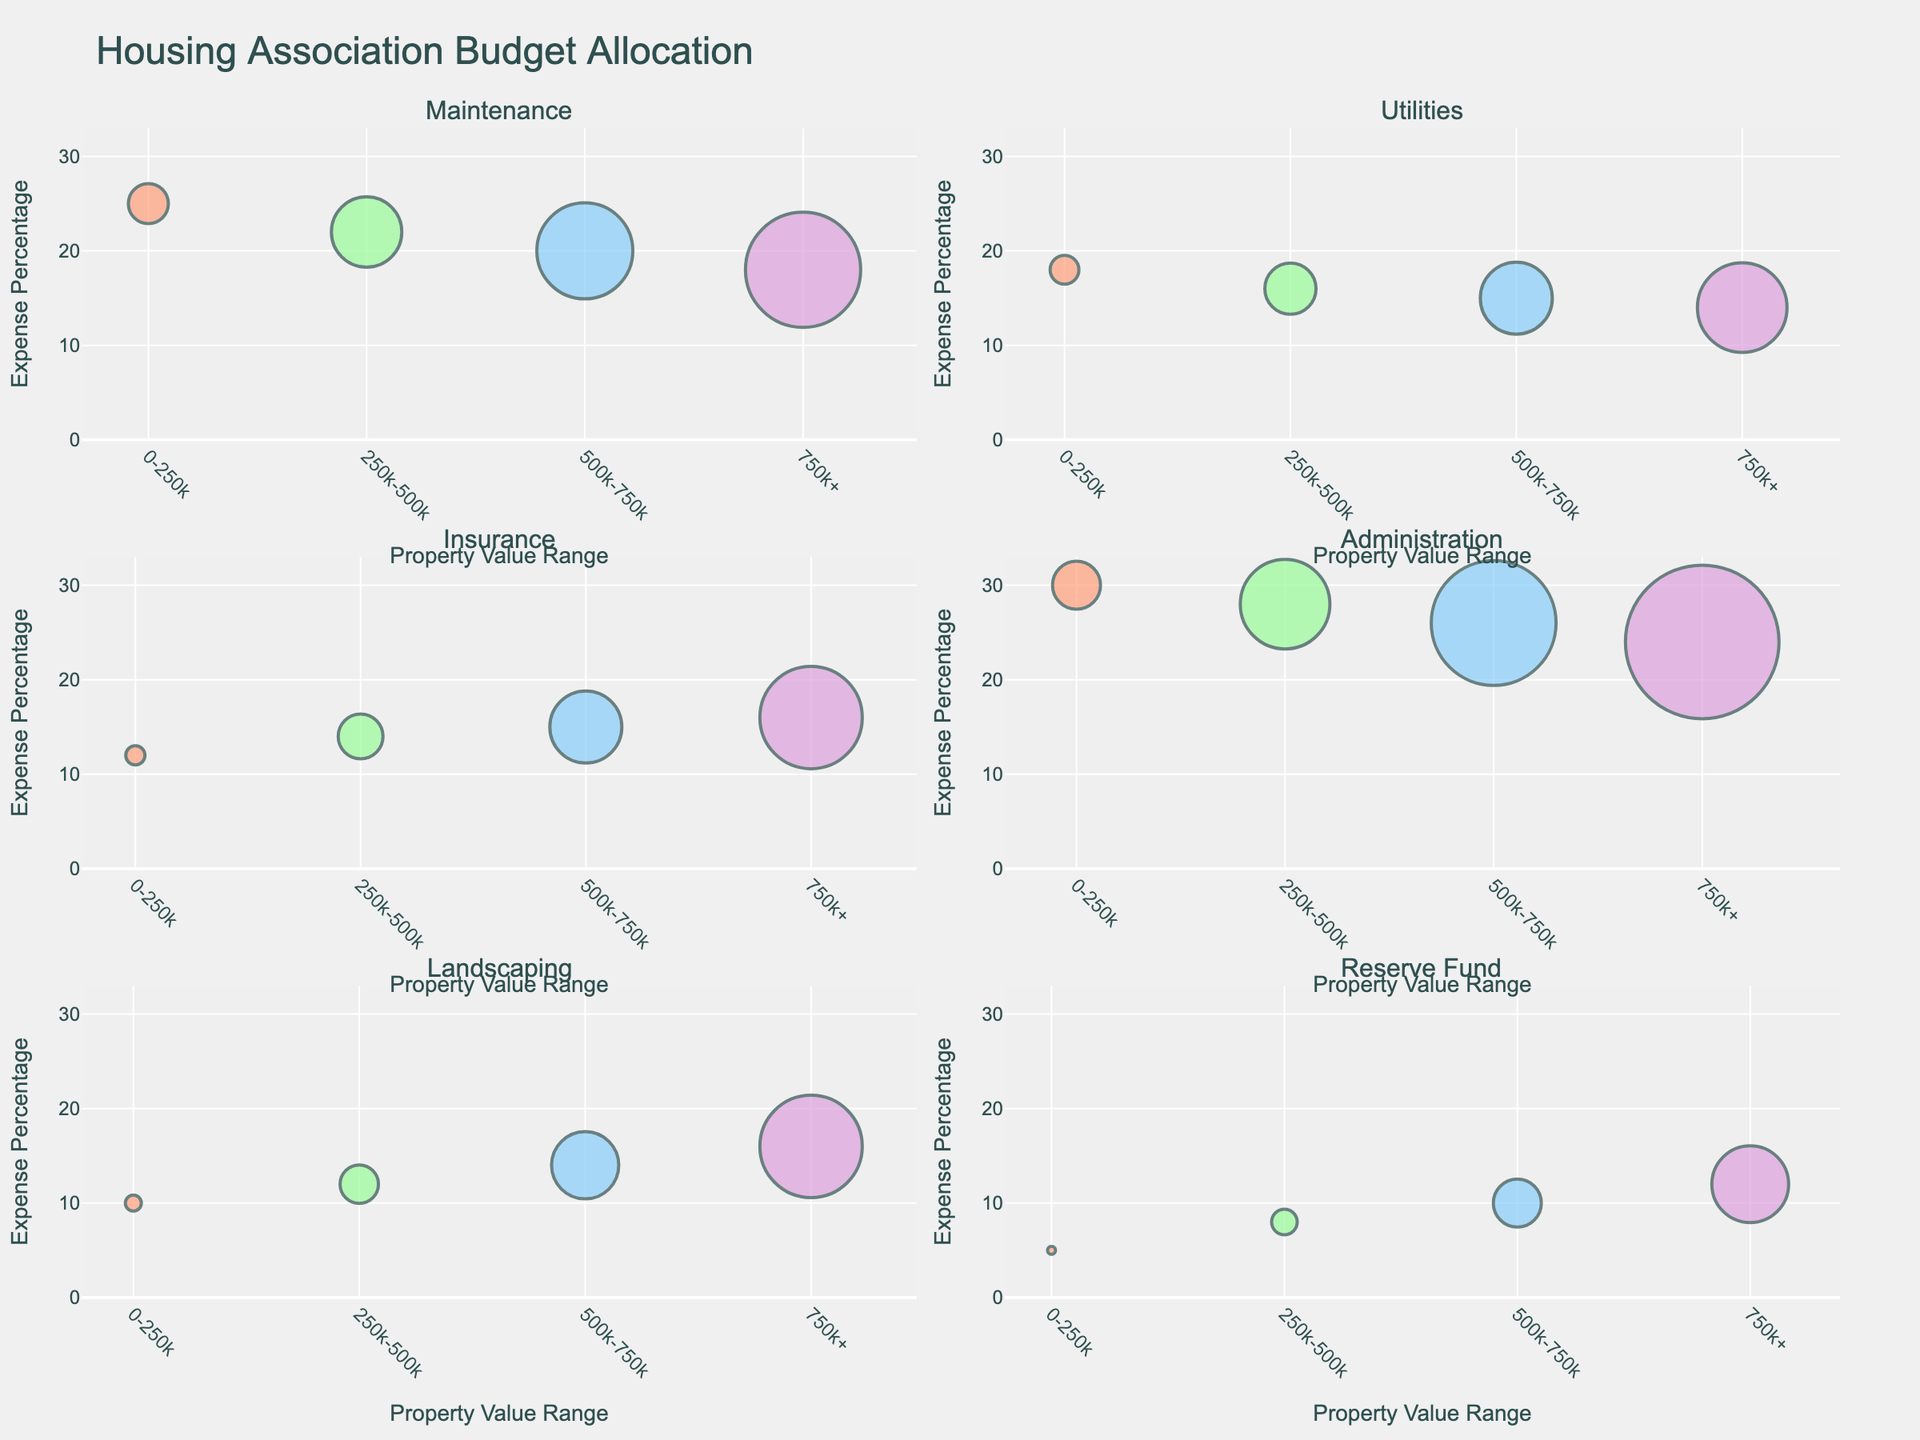What is the title of the figure? The title is located at the top-center of the figure. It is typically meant to provide a succinct description of what the figure is about.
Answer: Housing Association Budget Allocation How are the colors used in the figure? The colors represent different property value ranges. For example, #FFA07A for 0-250k, #98FB98 for 250k-500k, #87CEFA for 500k-750k, and #DDA0DD for 750k+. This helps to easily distinguish expense categories based on property values visually.
Answer: Different property value ranges How does the "Maintenance" expense percentage vary across the property value ranges? Each bubble's vertical position indicates the expense percentage for the "Maintenance" category. By examining these positions, we can see the expense percentages for different property value ranges.
Answer: It decreases as property value increases Which category has the highest budget amount in the 750k+ property value range? Locate the largest bubble in the subplot containing the "750k+" range and check the associated category.
Answer: Administration What is the difference in the budget amount for "Utilities" between the 0-250k and 750k+ property value ranges? Find the sizes of the bubbles for "Utilities" in both 0-250k and 750k+ ranges, then calculate the difference in budget amounts.
Answer: $190,000 How does the "Insurance" expense percentage change from the 0-250k to 750k+ property value range? Look at the vertical position (expense percentage) of the bubbles in the "Insurance" category subplot for both 0-250k and 750k+ ranges, then ascertain the change.
Answer: It increases from 12% to 16% What is the smallest budget amount among all categories for property values 500k-750k? Identify the smallest bubble in the subplot for 500k-750k property values and check its associated category and budget amount.
Answer: Reserve Fund with $150,000 Compare the expense percentage of "Landscaping" between the property value ranges of 0-250k and 750k+. Locate the vertical positions of the bubbles for "Landscaping" in both 0-250k and 750k+ ranges and compare their percentages.
Answer: It increases from 10% to 16% What is the sum of the budget amounts for "Administration" and "Maintenance" for the 500k-750k property value range? Add the budget amounts found in the bubbles for "Administration" and "Maintenance" under the 500k-750k range.
Answer: $690,000 Which category seems to have a consistent decrease in its expense percentage as property values increase? Spot the category subplot where the vertical positions of the bubbles (expense percentages) decrease from left to right across property value ranges.
Answer: Maintenance 